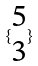<formula> <loc_0><loc_0><loc_500><loc_500>\{ \begin{matrix} 5 \\ 3 \end{matrix} \}</formula> 